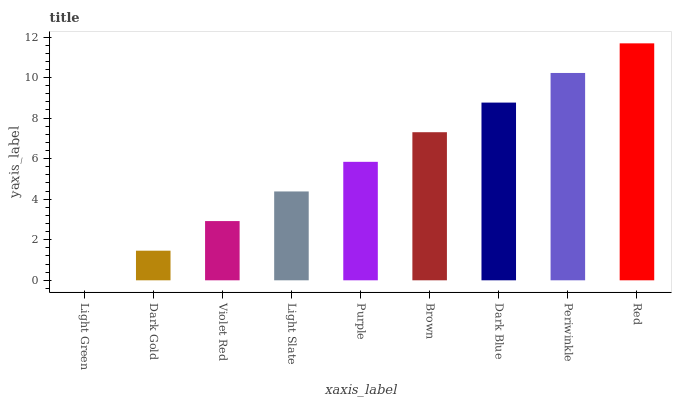Is Light Green the minimum?
Answer yes or no. Yes. Is Red the maximum?
Answer yes or no. Yes. Is Dark Gold the minimum?
Answer yes or no. No. Is Dark Gold the maximum?
Answer yes or no. No. Is Dark Gold greater than Light Green?
Answer yes or no. Yes. Is Light Green less than Dark Gold?
Answer yes or no. Yes. Is Light Green greater than Dark Gold?
Answer yes or no. No. Is Dark Gold less than Light Green?
Answer yes or no. No. Is Purple the high median?
Answer yes or no. Yes. Is Purple the low median?
Answer yes or no. Yes. Is Light Slate the high median?
Answer yes or no. No. Is Dark Gold the low median?
Answer yes or no. No. 